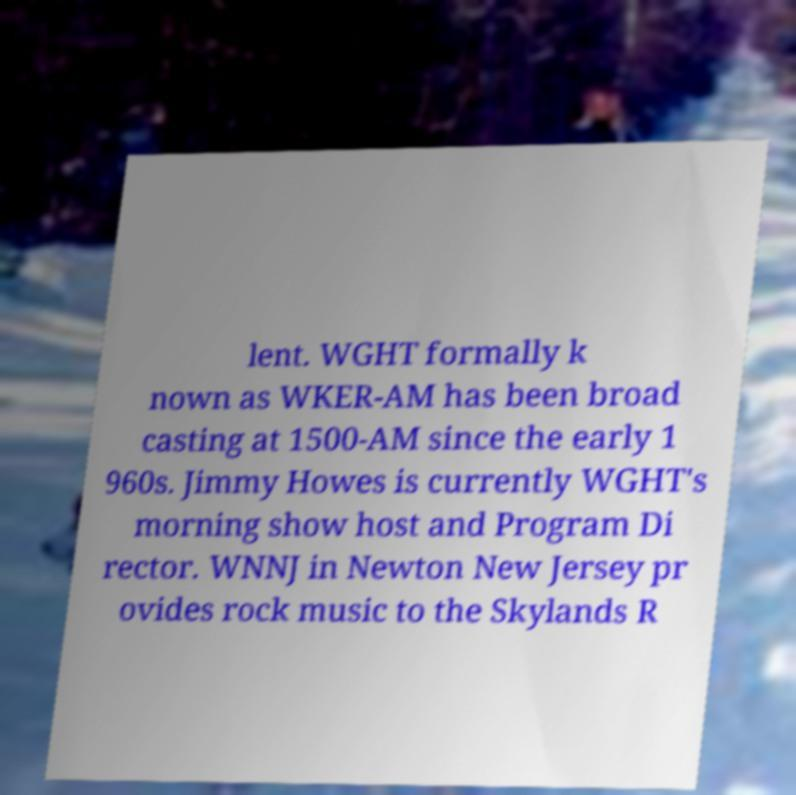Could you extract and type out the text from this image? lent. WGHT formally k nown as WKER-AM has been broad casting at 1500-AM since the early 1 960s. Jimmy Howes is currently WGHT's morning show host and Program Di rector. WNNJ in Newton New Jersey pr ovides rock music to the Skylands R 